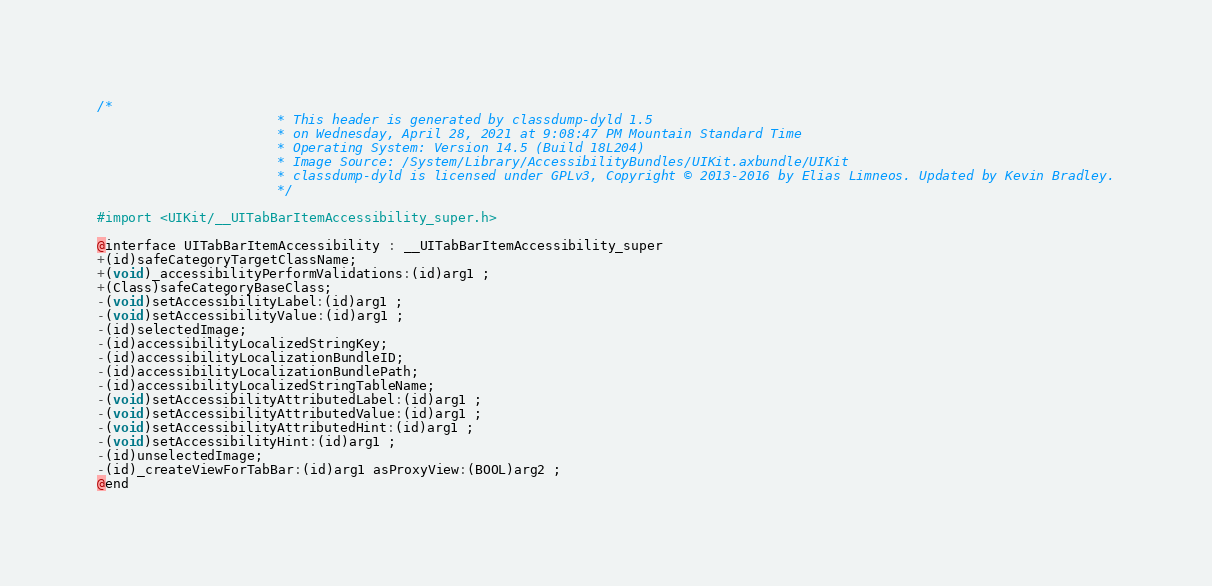Convert code to text. <code><loc_0><loc_0><loc_500><loc_500><_C_>/*
                       * This header is generated by classdump-dyld 1.5
                       * on Wednesday, April 28, 2021 at 9:08:47 PM Mountain Standard Time
                       * Operating System: Version 14.5 (Build 18L204)
                       * Image Source: /System/Library/AccessibilityBundles/UIKit.axbundle/UIKit
                       * classdump-dyld is licensed under GPLv3, Copyright © 2013-2016 by Elias Limneos. Updated by Kevin Bradley.
                       */

#import <UIKit/__UITabBarItemAccessibility_super.h>

@interface UITabBarItemAccessibility : __UITabBarItemAccessibility_super
+(id)safeCategoryTargetClassName;
+(void)_accessibilityPerformValidations:(id)arg1 ;
+(Class)safeCategoryBaseClass;
-(void)setAccessibilityLabel:(id)arg1 ;
-(void)setAccessibilityValue:(id)arg1 ;
-(id)selectedImage;
-(id)accessibilityLocalizedStringKey;
-(id)accessibilityLocalizationBundleID;
-(id)accessibilityLocalizationBundlePath;
-(id)accessibilityLocalizedStringTableName;
-(void)setAccessibilityAttributedLabel:(id)arg1 ;
-(void)setAccessibilityAttributedValue:(id)arg1 ;
-(void)setAccessibilityAttributedHint:(id)arg1 ;
-(void)setAccessibilityHint:(id)arg1 ;
-(id)unselectedImage;
-(id)_createViewForTabBar:(id)arg1 asProxyView:(BOOL)arg2 ;
@end

</code> 